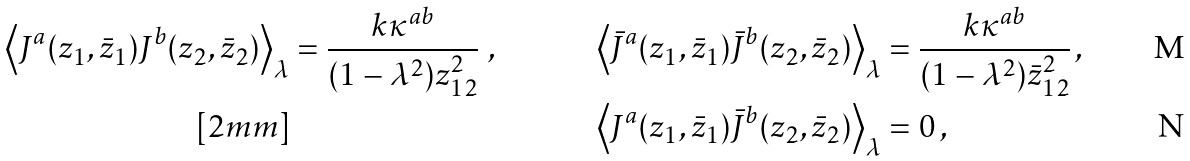<formula> <loc_0><loc_0><loc_500><loc_500>\left \langle J ^ { a } ( z _ { 1 } , \bar { z } _ { 1 } ) J ^ { b } ( z _ { 2 } , \bar { z } _ { 2 } ) \right \rangle _ { \lambda } & = \frac { k \kappa ^ { a b } } { ( 1 - \lambda ^ { 2 } ) z _ { 1 2 } ^ { 2 } } \ , & \left \langle \bar { J } ^ { a } ( z _ { 1 } , \bar { z } _ { 1 } ) \bar { J } ^ { b } ( z _ { 2 } , \bar { z } _ { 2 } ) \right \rangle _ { \lambda } & = \frac { k \kappa ^ { a b } } { ( 1 - \lambda ^ { 2 } ) \bar { z } _ { 1 2 } ^ { 2 } } \, , \\ [ 2 m m ] & & \left \langle J ^ { a } ( z _ { 1 } , \bar { z } _ { 1 } ) \bar { J } ^ { b } ( z _ { 2 } , \bar { z } _ { 2 } ) \right \rangle _ { \lambda } & = 0 \, ,</formula> 